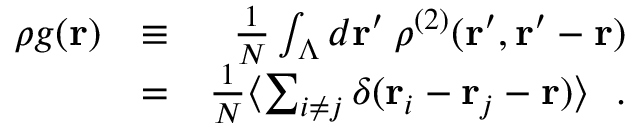<formula> <loc_0><loc_0><loc_500><loc_500>\begin{array} { r l r } { \rho g ( { r } ) } & { \equiv } & { \frac { 1 } { N } \int _ { \Lambda } d { r } ^ { \prime } \, \rho ^ { ( 2 ) } ( { r } ^ { \prime } , { r } ^ { \prime } - { r } ) } \\ & { = } & { \frac { 1 } { N } \langle \sum _ { i \neq j } \delta ( { r } _ { i } - { r } _ { j } - { r } ) \rangle . } \end{array}</formula> 